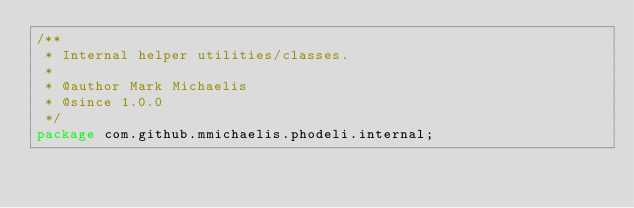Convert code to text. <code><loc_0><loc_0><loc_500><loc_500><_Java_>/**
 * Internal helper utilities/classes.
 *
 * @author Mark Michaelis
 * @since 1.0.0
 */
package com.github.mmichaelis.phodeli.internal;
</code> 